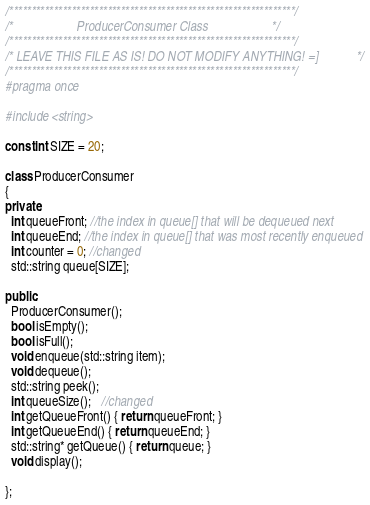<code> <loc_0><loc_0><loc_500><loc_500><_C++_>/****************************************************************/
/*                    ProducerConsumer Class                    */
/****************************************************************/
/* LEAVE THIS FILE AS IS! DO NOT MODIFY ANYTHING! =]            */
/****************************************************************/
#pragma once

#include <string>

const int SIZE = 20;

class ProducerConsumer
{
private:
  int queueFront; //the index in queue[] that will be dequeued next
  int queueEnd; //the index in queue[] that was most recently enqueued
  int counter = 0; //changed
  std::string queue[SIZE];

public:
  ProducerConsumer();
  bool isEmpty();
  bool isFull();
  void enqueue(std::string item);
  void dequeue();
  std::string peek();
  int queueSize();   //changed
  int getQueueFront() { return queueFront; }
  int getQueueEnd() { return queueEnd; }
  std::string* getQueue() { return queue; }
  void display();

};
</code> 